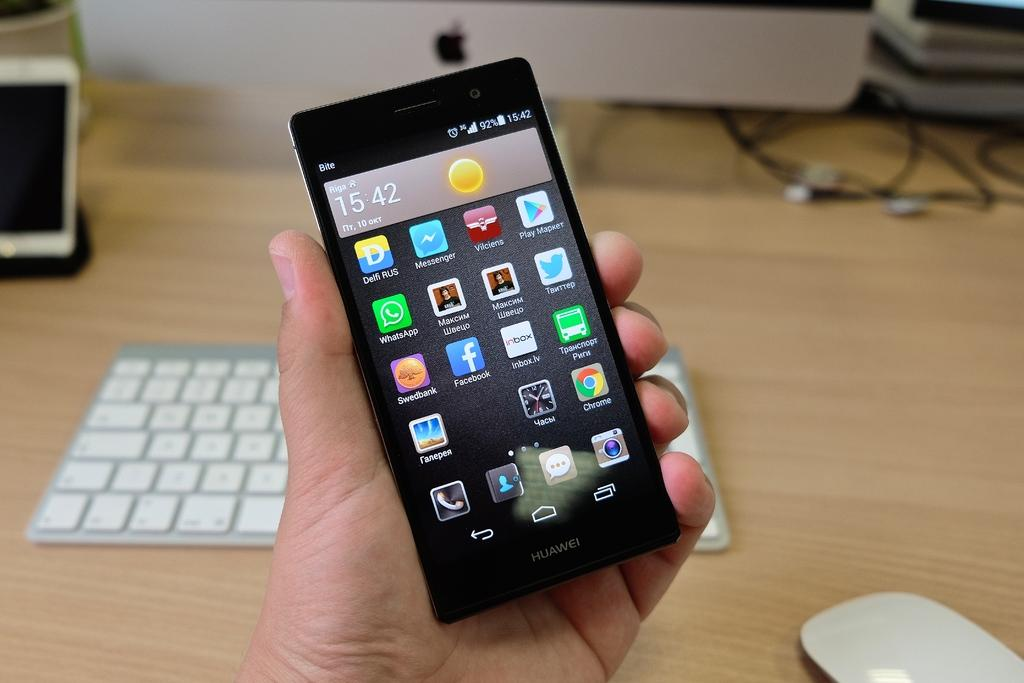Provide a one-sentence caption for the provided image. A person is holding a phone that says Huawei and shows the time 15:42. 